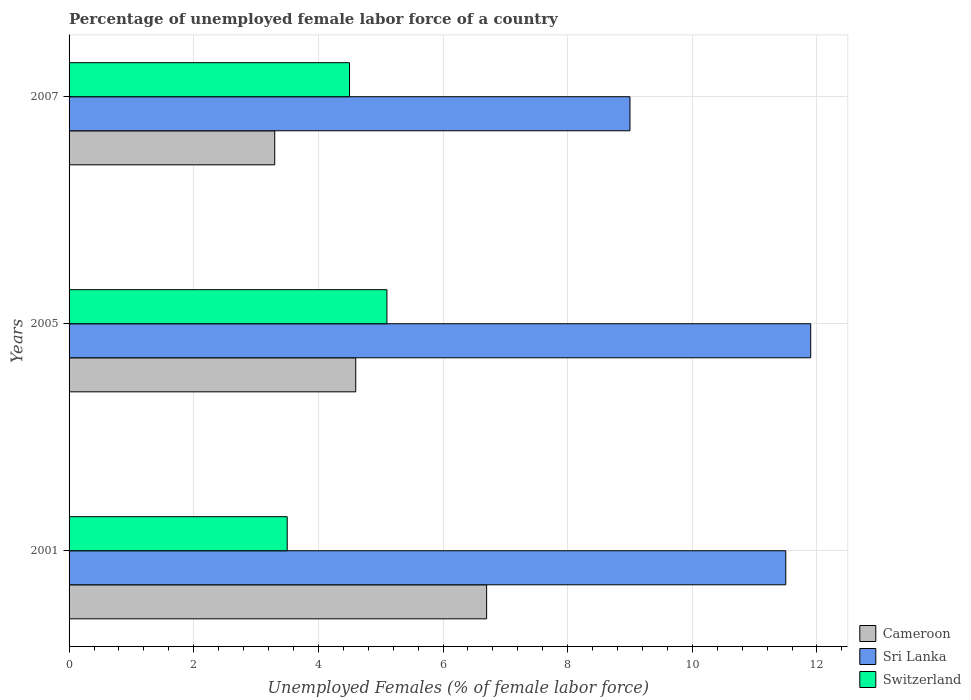How many different coloured bars are there?
Your answer should be compact. 3. How many groups of bars are there?
Your answer should be compact. 3. How many bars are there on the 2nd tick from the top?
Give a very brief answer. 3. How many bars are there on the 2nd tick from the bottom?
Your response must be concise. 3. Across all years, what is the maximum percentage of unemployed female labor force in Sri Lanka?
Your response must be concise. 11.9. Across all years, what is the minimum percentage of unemployed female labor force in Sri Lanka?
Give a very brief answer. 9. In which year was the percentage of unemployed female labor force in Sri Lanka maximum?
Your response must be concise. 2005. In which year was the percentage of unemployed female labor force in Sri Lanka minimum?
Keep it short and to the point. 2007. What is the total percentage of unemployed female labor force in Sri Lanka in the graph?
Keep it short and to the point. 32.4. What is the difference between the percentage of unemployed female labor force in Sri Lanka in 2001 and that in 2005?
Provide a short and direct response. -0.4. What is the difference between the percentage of unemployed female labor force in Cameroon in 2007 and the percentage of unemployed female labor force in Switzerland in 2001?
Make the answer very short. -0.2. What is the average percentage of unemployed female labor force in Switzerland per year?
Your response must be concise. 4.37. In how many years, is the percentage of unemployed female labor force in Cameroon greater than 11.6 %?
Provide a short and direct response. 0. What is the ratio of the percentage of unemployed female labor force in Cameroon in 2005 to that in 2007?
Make the answer very short. 1.39. Is the percentage of unemployed female labor force in Cameroon in 2001 less than that in 2007?
Your answer should be compact. No. Is the difference between the percentage of unemployed female labor force in Sri Lanka in 2001 and 2005 greater than the difference between the percentage of unemployed female labor force in Switzerland in 2001 and 2005?
Ensure brevity in your answer.  Yes. What is the difference between the highest and the second highest percentage of unemployed female labor force in Cameroon?
Provide a short and direct response. 2.1. What is the difference between the highest and the lowest percentage of unemployed female labor force in Sri Lanka?
Offer a very short reply. 2.9. Is the sum of the percentage of unemployed female labor force in Switzerland in 2001 and 2005 greater than the maximum percentage of unemployed female labor force in Cameroon across all years?
Your response must be concise. Yes. What does the 2nd bar from the top in 2007 represents?
Your response must be concise. Sri Lanka. What does the 2nd bar from the bottom in 2007 represents?
Provide a succinct answer. Sri Lanka. Is it the case that in every year, the sum of the percentage of unemployed female labor force in Switzerland and percentage of unemployed female labor force in Cameroon is greater than the percentage of unemployed female labor force in Sri Lanka?
Offer a terse response. No. Are all the bars in the graph horizontal?
Give a very brief answer. Yes. What is the difference between two consecutive major ticks on the X-axis?
Provide a succinct answer. 2. Are the values on the major ticks of X-axis written in scientific E-notation?
Ensure brevity in your answer.  No. Does the graph contain any zero values?
Make the answer very short. No. Does the graph contain grids?
Ensure brevity in your answer.  Yes. How are the legend labels stacked?
Offer a very short reply. Vertical. What is the title of the graph?
Your response must be concise. Percentage of unemployed female labor force of a country. Does "Liberia" appear as one of the legend labels in the graph?
Give a very brief answer. No. What is the label or title of the X-axis?
Make the answer very short. Unemployed Females (% of female labor force). What is the label or title of the Y-axis?
Provide a short and direct response. Years. What is the Unemployed Females (% of female labor force) of Cameroon in 2001?
Your answer should be compact. 6.7. What is the Unemployed Females (% of female labor force) of Sri Lanka in 2001?
Provide a short and direct response. 11.5. What is the Unemployed Females (% of female labor force) of Cameroon in 2005?
Your answer should be very brief. 4.6. What is the Unemployed Females (% of female labor force) of Sri Lanka in 2005?
Your answer should be very brief. 11.9. What is the Unemployed Females (% of female labor force) in Switzerland in 2005?
Your response must be concise. 5.1. What is the Unemployed Females (% of female labor force) in Cameroon in 2007?
Offer a terse response. 3.3. What is the Unemployed Females (% of female labor force) in Switzerland in 2007?
Ensure brevity in your answer.  4.5. Across all years, what is the maximum Unemployed Females (% of female labor force) in Cameroon?
Your response must be concise. 6.7. Across all years, what is the maximum Unemployed Females (% of female labor force) of Sri Lanka?
Ensure brevity in your answer.  11.9. Across all years, what is the maximum Unemployed Females (% of female labor force) in Switzerland?
Give a very brief answer. 5.1. Across all years, what is the minimum Unemployed Females (% of female labor force) in Cameroon?
Give a very brief answer. 3.3. Across all years, what is the minimum Unemployed Females (% of female labor force) of Switzerland?
Your response must be concise. 3.5. What is the total Unemployed Females (% of female labor force) in Cameroon in the graph?
Give a very brief answer. 14.6. What is the total Unemployed Females (% of female labor force) in Sri Lanka in the graph?
Offer a terse response. 32.4. What is the total Unemployed Females (% of female labor force) in Switzerland in the graph?
Your answer should be compact. 13.1. What is the difference between the Unemployed Females (% of female labor force) in Sri Lanka in 2001 and that in 2005?
Your answer should be very brief. -0.4. What is the difference between the Unemployed Females (% of female labor force) in Cameroon in 2001 and that in 2007?
Offer a terse response. 3.4. What is the difference between the Unemployed Females (% of female labor force) in Switzerland in 2005 and that in 2007?
Provide a short and direct response. 0.6. What is the difference between the Unemployed Females (% of female labor force) of Cameroon in 2001 and the Unemployed Females (% of female labor force) of Sri Lanka in 2005?
Provide a succinct answer. -5.2. What is the difference between the Unemployed Females (% of female labor force) of Sri Lanka in 2001 and the Unemployed Females (% of female labor force) of Switzerland in 2005?
Keep it short and to the point. 6.4. What is the difference between the Unemployed Females (% of female labor force) of Cameroon in 2001 and the Unemployed Females (% of female labor force) of Sri Lanka in 2007?
Keep it short and to the point. -2.3. What is the difference between the Unemployed Females (% of female labor force) of Cameroon in 2001 and the Unemployed Females (% of female labor force) of Switzerland in 2007?
Ensure brevity in your answer.  2.2. What is the difference between the Unemployed Females (% of female labor force) of Sri Lanka in 2005 and the Unemployed Females (% of female labor force) of Switzerland in 2007?
Offer a very short reply. 7.4. What is the average Unemployed Females (% of female labor force) in Cameroon per year?
Ensure brevity in your answer.  4.87. What is the average Unemployed Females (% of female labor force) of Switzerland per year?
Offer a terse response. 4.37. In the year 2001, what is the difference between the Unemployed Females (% of female labor force) of Cameroon and Unemployed Females (% of female labor force) of Sri Lanka?
Ensure brevity in your answer.  -4.8. In the year 2001, what is the difference between the Unemployed Females (% of female labor force) in Cameroon and Unemployed Females (% of female labor force) in Switzerland?
Offer a terse response. 3.2. In the year 2001, what is the difference between the Unemployed Females (% of female labor force) of Sri Lanka and Unemployed Females (% of female labor force) of Switzerland?
Provide a short and direct response. 8. In the year 2005, what is the difference between the Unemployed Females (% of female labor force) in Cameroon and Unemployed Females (% of female labor force) in Switzerland?
Offer a terse response. -0.5. In the year 2005, what is the difference between the Unemployed Females (% of female labor force) in Sri Lanka and Unemployed Females (% of female labor force) in Switzerland?
Make the answer very short. 6.8. In the year 2007, what is the difference between the Unemployed Females (% of female labor force) of Sri Lanka and Unemployed Females (% of female labor force) of Switzerland?
Offer a terse response. 4.5. What is the ratio of the Unemployed Females (% of female labor force) in Cameroon in 2001 to that in 2005?
Your response must be concise. 1.46. What is the ratio of the Unemployed Females (% of female labor force) of Sri Lanka in 2001 to that in 2005?
Give a very brief answer. 0.97. What is the ratio of the Unemployed Females (% of female labor force) of Switzerland in 2001 to that in 2005?
Give a very brief answer. 0.69. What is the ratio of the Unemployed Females (% of female labor force) of Cameroon in 2001 to that in 2007?
Provide a succinct answer. 2.03. What is the ratio of the Unemployed Females (% of female labor force) of Sri Lanka in 2001 to that in 2007?
Keep it short and to the point. 1.28. What is the ratio of the Unemployed Females (% of female labor force) in Switzerland in 2001 to that in 2007?
Provide a short and direct response. 0.78. What is the ratio of the Unemployed Females (% of female labor force) in Cameroon in 2005 to that in 2007?
Ensure brevity in your answer.  1.39. What is the ratio of the Unemployed Females (% of female labor force) of Sri Lanka in 2005 to that in 2007?
Ensure brevity in your answer.  1.32. What is the ratio of the Unemployed Females (% of female labor force) in Switzerland in 2005 to that in 2007?
Your response must be concise. 1.13. What is the difference between the highest and the second highest Unemployed Females (% of female labor force) in Cameroon?
Make the answer very short. 2.1. What is the difference between the highest and the second highest Unemployed Females (% of female labor force) of Sri Lanka?
Your response must be concise. 0.4. What is the difference between the highest and the lowest Unemployed Females (% of female labor force) of Cameroon?
Your answer should be compact. 3.4. What is the difference between the highest and the lowest Unemployed Females (% of female labor force) of Switzerland?
Offer a very short reply. 1.6. 